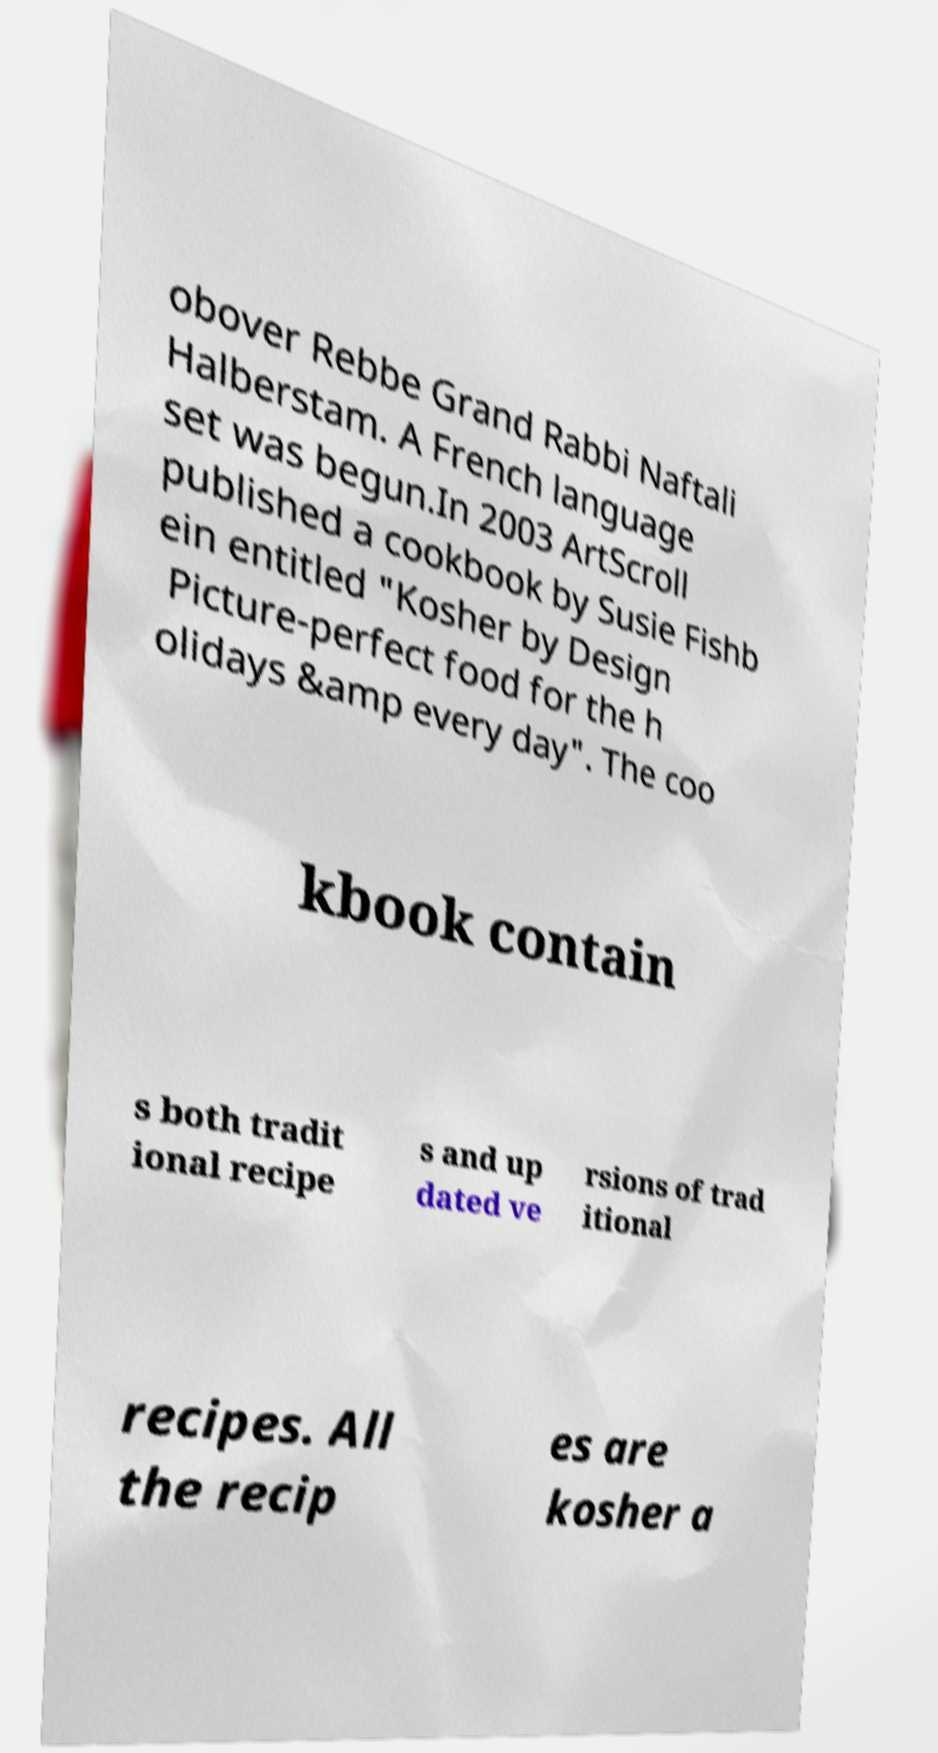Can you accurately transcribe the text from the provided image for me? obover Rebbe Grand Rabbi Naftali Halberstam. A French language set was begun.In 2003 ArtScroll published a cookbook by Susie Fishb ein entitled "Kosher by Design Picture-perfect food for the h olidays &amp every day". The coo kbook contain s both tradit ional recipe s and up dated ve rsions of trad itional recipes. All the recip es are kosher a 